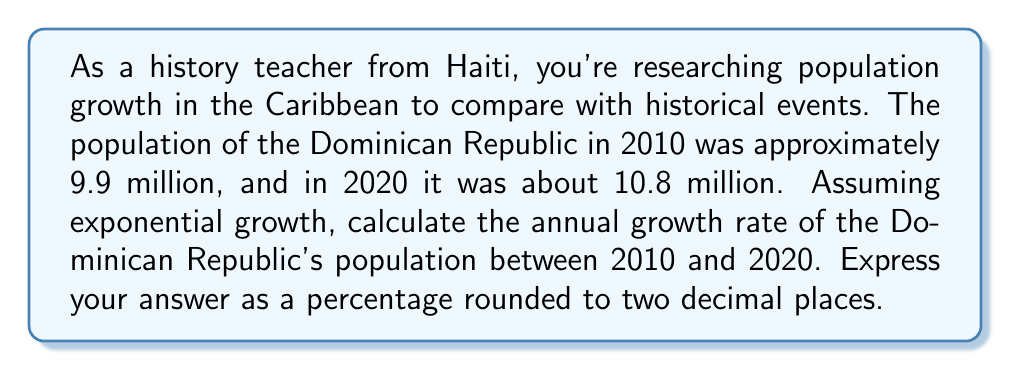Show me your answer to this math problem. To solve this problem, we'll use the exponential growth formula:

$$P(t) = P_0 \cdot e^{rt}$$

Where:
$P(t)$ is the population at time $t$
$P_0$ is the initial population
$r$ is the growth rate
$t$ is the time period

We know:
$P_0 = 9.9$ million (2010 population)
$P(t) = 10.8$ million (2020 population)
$t = 10$ years

Let's substitute these values into the equation:

$$10.8 = 9.9 \cdot e^{10r}$$

Now, we need to solve for $r$:

1) Divide both sides by 9.9:
   $$\frac{10.8}{9.9} = e^{10r}$$

2) Take the natural logarithm of both sides:
   $$\ln(\frac{10.8}{9.9}) = 10r$$

3) Solve for $r$:
   $$r = \frac{\ln(\frac{10.8}{9.9})}{10}$$

4) Calculate the value:
   $$r = \frac{\ln(1.0909)}{10} \approx 0.008689$$

5) Convert to a percentage:
   $$r \approx 0.008689 \cdot 100\% = 0.8689\%$$

6) Round to two decimal places:
   $$r \approx 0.87\%$$
Answer: The annual population growth rate of the Dominican Republic between 2010 and 2020 was approximately 0.87%. 